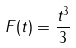Convert formula to latex. <formula><loc_0><loc_0><loc_500><loc_500>F ( t ) = \frac { t ^ { 3 } } { 3 }</formula> 